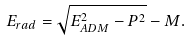Convert formula to latex. <formula><loc_0><loc_0><loc_500><loc_500>E _ { r a d } = \sqrt { E _ { A D M } ^ { 2 } - P ^ { 2 } } - M .</formula> 